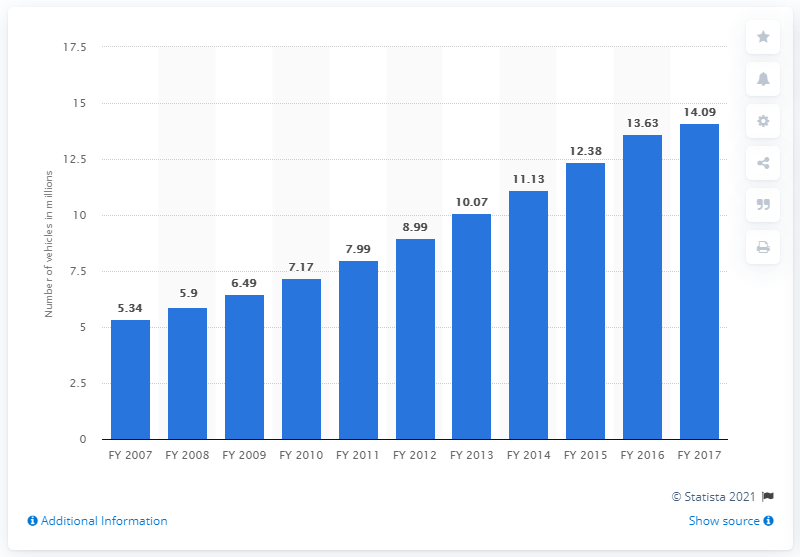Draw attention to some important aspects in this diagram. At the end of fiscal year 2017, there were 14,090 registered vehicles in the state of Rajasthan. 